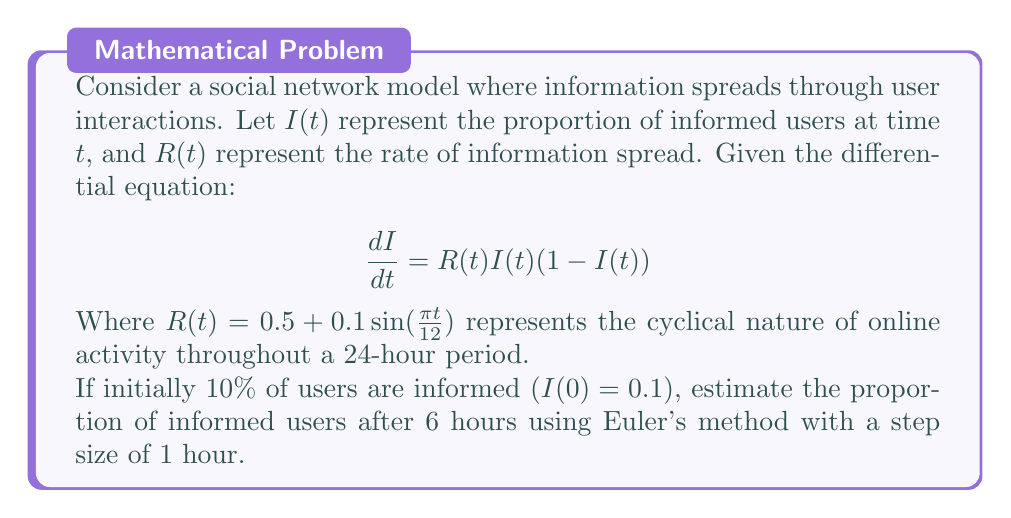Could you help me with this problem? To solve this problem, we'll use Euler's method to approximate the solution to the differential equation. Euler's method is given by:

$$I_{n+1} = I_n + h \cdot f(t_n, I_n)$$

Where $h$ is the step size, and $f(t, I) = R(t)I(t)(1-I(t))$.

Given:
- Initial condition: $I(0) = 0.1$
- Step size: $h = 1$ hour
- Time to estimate: $t = 6$ hours

We'll calculate 6 steps:

Step 1 $(t = 0)$:
$R(0) = 0.5 + 0.1\sin(0) = 0.5$
$f(0, 0.1) = 0.5 \cdot 0.1 \cdot (1-0.1) = 0.045$
$I_1 = 0.1 + 1 \cdot 0.045 = 0.145$

Step 2 $(t = 1)$:
$R(1) = 0.5 + 0.1\sin(\frac{\pi}{12}) \approx 0.5262$
$f(1, 0.145) = 0.5262 \cdot 0.145 \cdot (1-0.145) \approx 0.0652$
$I_2 = 0.145 + 1 \cdot 0.0652 = 0.2102$

Step 3 $(t = 2)$:
$R(2) = 0.5 + 0.1\sin(\frac{\pi}{6}) \approx 0.55$
$f(2, 0.2102) = 0.55 \cdot 0.2102 \cdot (1-0.2102) \approx 0.0912$
$I_3 = 0.2102 + 1 \cdot 0.0912 = 0.3014$

Step 4 $(t = 3)$:
$R(3) = 0.5 + 0.1\sin(\frac{\pi}{4}) \approx 0.5707$
$f(3, 0.3014) = 0.5707 \cdot 0.3014 \cdot (1-0.3014) \approx 0.1206$
$I_4 = 0.3014 + 1 \cdot 0.1206 = 0.4220$

Step 5 $(t = 4)$:
$R(4) = 0.5 + 0.1\sin(\frac{\pi}{3}) \approx 0.5866$
$f(4, 0.4220) = 0.5866 \cdot 0.4220 \cdot (1-0.4220) \approx 0.1431$
$I_5 = 0.4220 + 1 \cdot 0.1431 = 0.5651$

Step 6 $(t = 5)$:
$R(5) = 0.5 + 0.1\sin(\frac{5\pi}{12}) \approx 0.5966$
$f(5, 0.5651) = 0.5966 \cdot 0.5651 \cdot (1-0.5651) \approx 0.1465$
$I_6 = 0.5651 + 1 \cdot 0.1465 = 0.7116$

Therefore, after 6 hours, the estimated proportion of informed users is approximately 0.7116 or 71.16%.
Answer: $I(6) \approx 0.7116$ or $71.16\%$ 